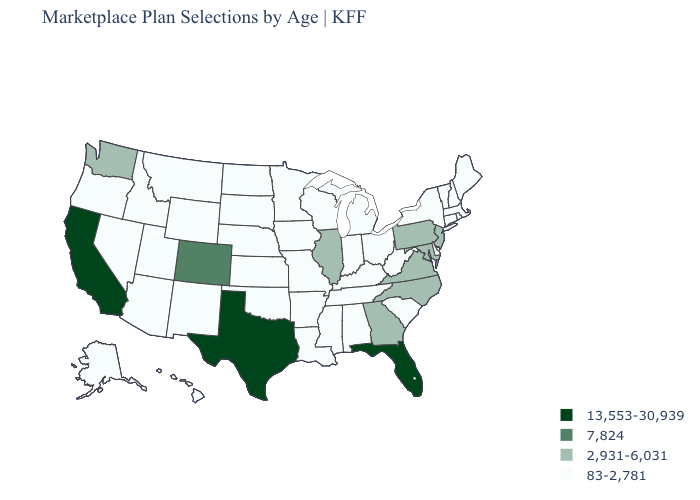Does the map have missing data?
Be succinct. No. What is the value of Iowa?
Short answer required. 83-2,781. Name the states that have a value in the range 83-2,781?
Short answer required. Alabama, Alaska, Arizona, Arkansas, Connecticut, Delaware, Hawaii, Idaho, Indiana, Iowa, Kansas, Kentucky, Louisiana, Maine, Massachusetts, Michigan, Minnesota, Mississippi, Missouri, Montana, Nebraska, Nevada, New Hampshire, New Mexico, New York, North Dakota, Ohio, Oklahoma, Oregon, Rhode Island, South Carolina, South Dakota, Tennessee, Utah, Vermont, West Virginia, Wisconsin, Wyoming. What is the highest value in states that border Vermont?
Give a very brief answer. 83-2,781. Name the states that have a value in the range 2,931-6,031?
Quick response, please. Georgia, Illinois, Maryland, New Jersey, North Carolina, Pennsylvania, Virginia, Washington. Does Illinois have the highest value in the MidWest?
Give a very brief answer. Yes. Name the states that have a value in the range 13,553-30,939?
Give a very brief answer. California, Florida, Texas. Does Michigan have the lowest value in the USA?
Be succinct. Yes. Among the states that border New Hampshire , which have the highest value?
Write a very short answer. Maine, Massachusetts, Vermont. What is the lowest value in states that border Oklahoma?
Give a very brief answer. 83-2,781. Name the states that have a value in the range 7,824?
Keep it brief. Colorado. Does Wisconsin have the lowest value in the MidWest?
Keep it brief. Yes. What is the value of Indiana?
Concise answer only. 83-2,781. Does the map have missing data?
Quick response, please. No. Is the legend a continuous bar?
Quick response, please. No. 